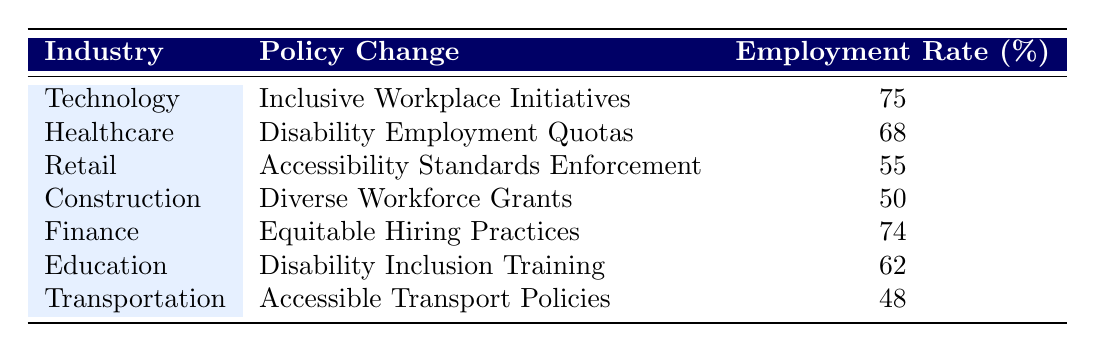What is the employment rate in the Technology industry? The table indicates that the employment rate for the Technology industry is listed directly under the Employment Rate column. It shows 75%.
Answer: 75% Which industry has the lowest employment rate? By examining the Employment Rate column, we can see that the Transportation industry has the lowest rate at 48%.
Answer: 48% Is there a direct correlation between 'Inclusive Workplace Initiatives' and employment rates? The Technology industry, which employs 'Inclusive Workplace Initiatives,' has an employment rate of 75%. However, one cannot definitively claim a correlation solely from this single data point without additional data.
Answer: No What is the average employment rate across all industries listed? To calculate the average, we sum the employment rates: (75 + 68 + 55 + 50 + 74 + 62 + 48) = 432. There are 7 industries, so we divide 432 by 7, giving us an average of approximately 61.71%.
Answer: 61.71% Do Healthcare and Finance industries have higher employment rates than Retail and Construction? The employment rates are: Healthcare (68%), Finance (74%), Retail (55%), and Construction (50%). Both Healthcare and Finance have higher rates than Retail and Construction.
Answer: Yes How much higher is the employment rate in the Finance industry compared to the Transportation industry? The employment rate in Finance is 74% while in Transportation, it is 48%. The difference is calculated as 74 - 48 = 26%.
Answer: 26% Which policy change is associated with the highest employment rate and what is that rate? The Technology industry's 'Inclusive Workplace Initiatives' correlate with the highest employment rate listed, which is 75%.
Answer: 75% Are the employment rates consistent across all industries? The employment rates vary significantly, ranging from 48% in Transportation to 75% in Technology, which indicates inconsistency.
Answer: No 